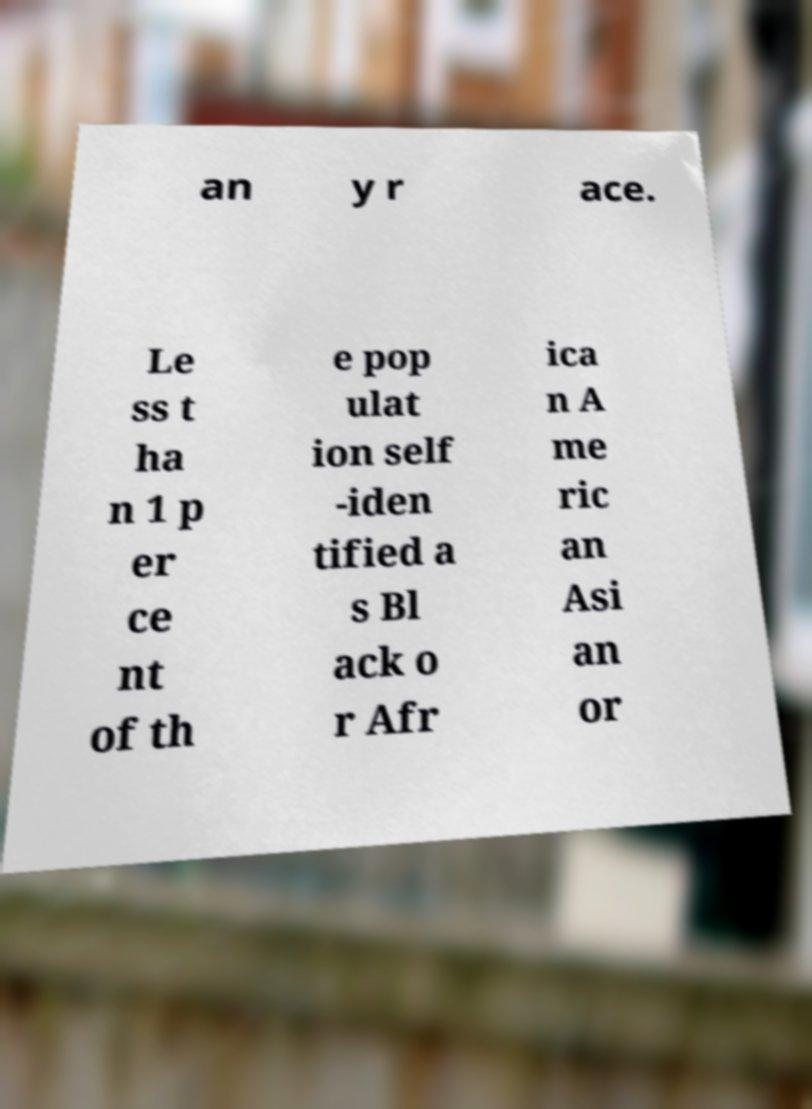For documentation purposes, I need the text within this image transcribed. Could you provide that? an y r ace. Le ss t ha n 1 p er ce nt of th e pop ulat ion self -iden tified a s Bl ack o r Afr ica n A me ric an Asi an or 